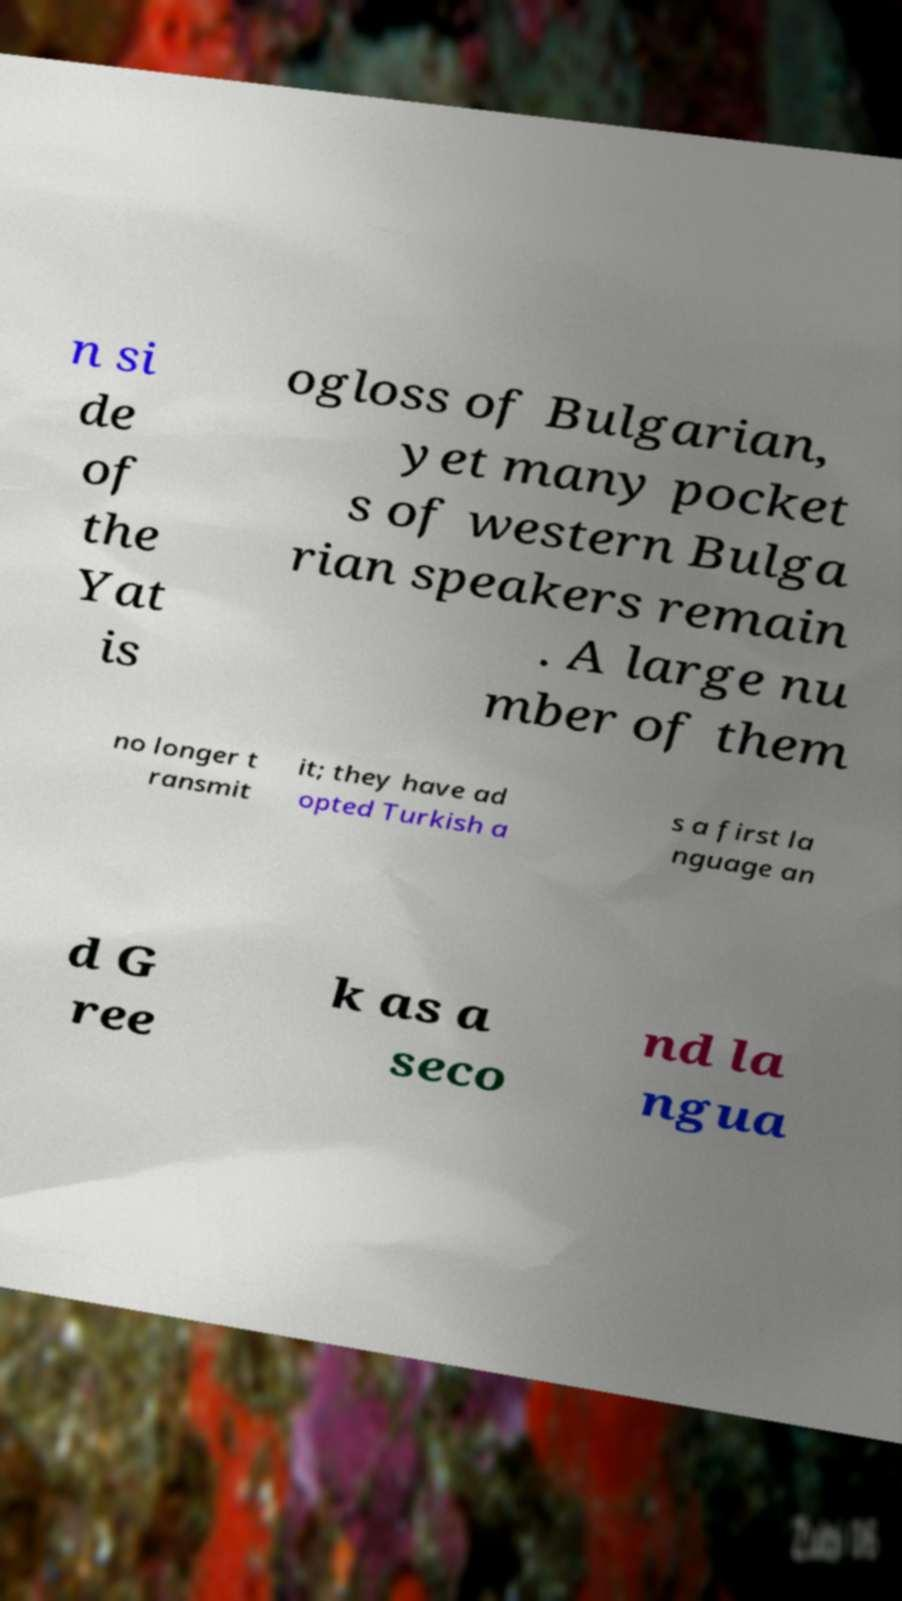Can you read and provide the text displayed in the image?This photo seems to have some interesting text. Can you extract and type it out for me? n si de of the Yat is ogloss of Bulgarian, yet many pocket s of western Bulga rian speakers remain . A large nu mber of them no longer t ransmit it; they have ad opted Turkish a s a first la nguage an d G ree k as a seco nd la ngua 